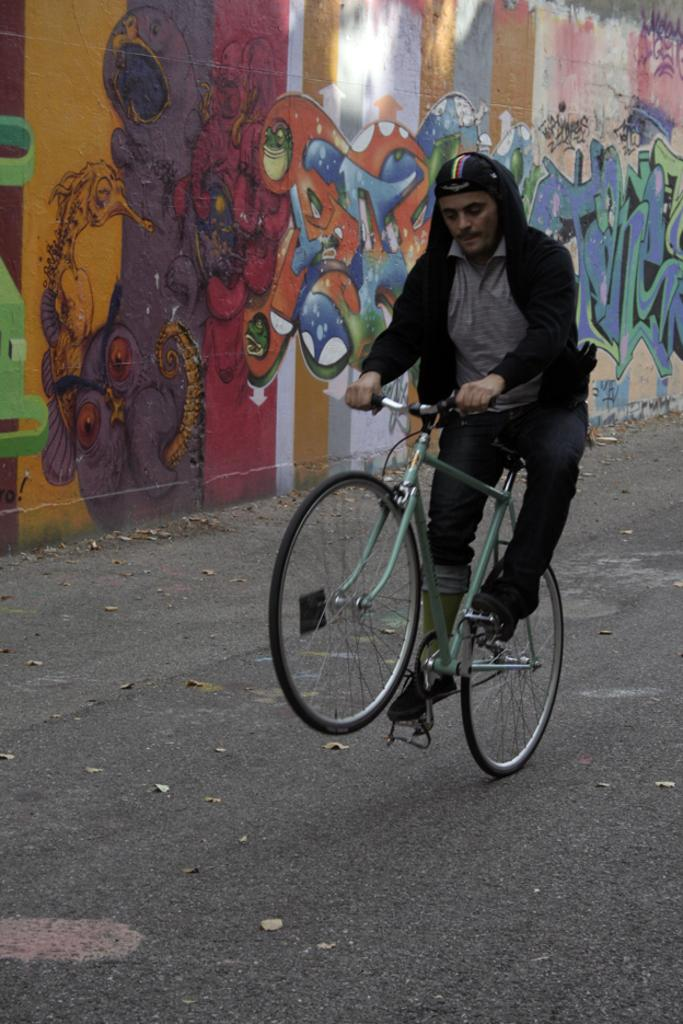Who is present in the image? There is a man in the image. What is the man doing in the image? The man is on a cycle in the image. What can be seen in the foreground of the image? There is a path visible in the image. What is visible in the background of the image? There is a wall in the background of the image, and there is art on the wall. What type of ground is the man cycling on in the image? The provided facts do not mention the type of ground in the image, so it cannot be determined. 